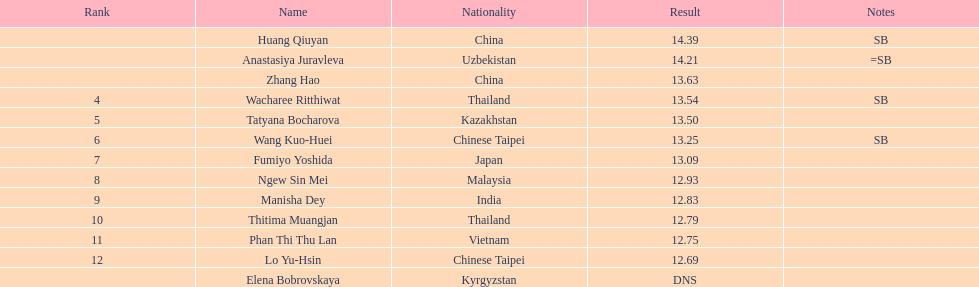How many athletes were from china? 2. 